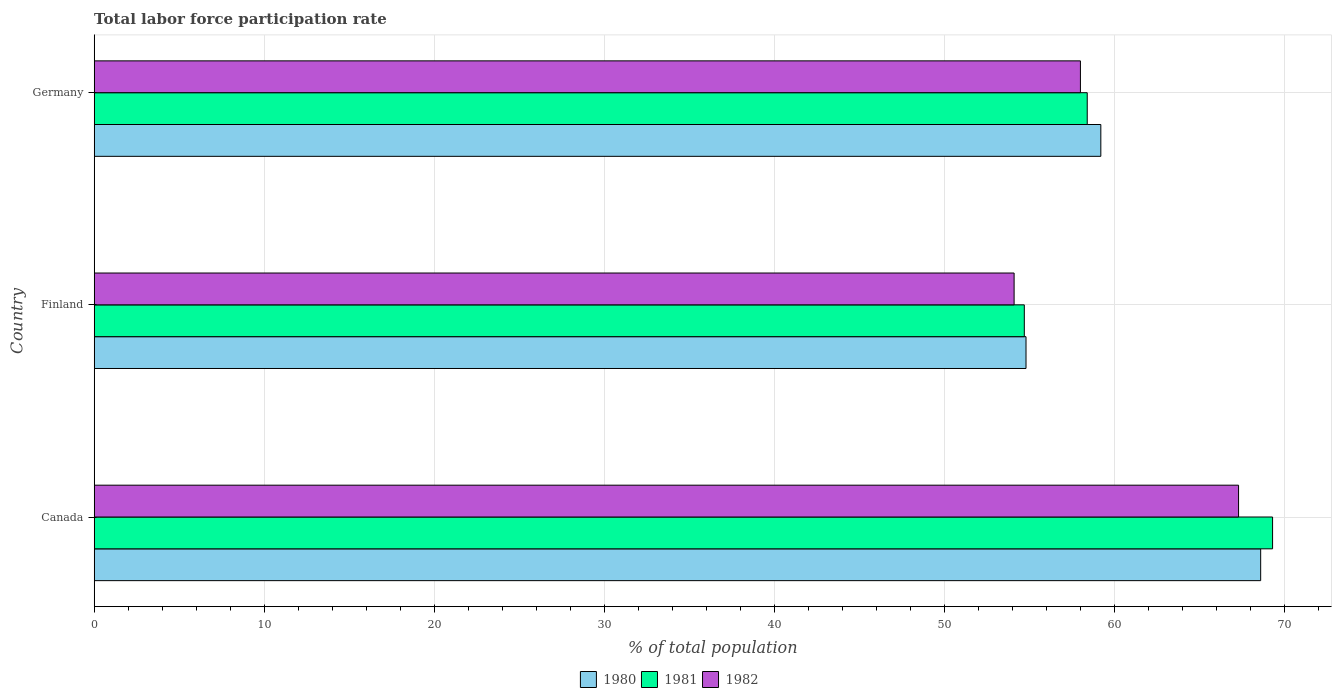How many different coloured bars are there?
Your answer should be compact. 3. How many groups of bars are there?
Make the answer very short. 3. Are the number of bars per tick equal to the number of legend labels?
Offer a terse response. Yes. Are the number of bars on each tick of the Y-axis equal?
Your answer should be compact. Yes. How many bars are there on the 1st tick from the bottom?
Your response must be concise. 3. What is the label of the 1st group of bars from the top?
Your response must be concise. Germany. In how many cases, is the number of bars for a given country not equal to the number of legend labels?
Provide a short and direct response. 0. What is the total labor force participation rate in 1981 in Germany?
Your answer should be compact. 58.4. Across all countries, what is the maximum total labor force participation rate in 1982?
Keep it short and to the point. 67.3. Across all countries, what is the minimum total labor force participation rate in 1982?
Make the answer very short. 54.1. What is the total total labor force participation rate in 1982 in the graph?
Your response must be concise. 179.4. What is the difference between the total labor force participation rate in 1981 in Canada and that in Germany?
Provide a short and direct response. 10.9. What is the difference between the total labor force participation rate in 1982 in Germany and the total labor force participation rate in 1980 in Finland?
Offer a very short reply. 3.2. What is the average total labor force participation rate in 1980 per country?
Provide a succinct answer. 60.87. What is the difference between the total labor force participation rate in 1981 and total labor force participation rate in 1982 in Germany?
Give a very brief answer. 0.4. In how many countries, is the total labor force participation rate in 1980 greater than 58 %?
Keep it short and to the point. 2. What is the ratio of the total labor force participation rate in 1981 in Canada to that in Germany?
Ensure brevity in your answer.  1.19. Is the difference between the total labor force participation rate in 1981 in Canada and Finland greater than the difference between the total labor force participation rate in 1982 in Canada and Finland?
Your answer should be very brief. Yes. What is the difference between the highest and the second highest total labor force participation rate in 1982?
Make the answer very short. 9.3. What is the difference between the highest and the lowest total labor force participation rate in 1980?
Keep it short and to the point. 13.8. What does the 3rd bar from the top in Finland represents?
Your answer should be very brief. 1980. Is it the case that in every country, the sum of the total labor force participation rate in 1982 and total labor force participation rate in 1980 is greater than the total labor force participation rate in 1981?
Make the answer very short. Yes. How many bars are there?
Your response must be concise. 9. How many countries are there in the graph?
Keep it short and to the point. 3. Does the graph contain any zero values?
Offer a very short reply. No. How many legend labels are there?
Give a very brief answer. 3. What is the title of the graph?
Your answer should be very brief. Total labor force participation rate. What is the label or title of the X-axis?
Your answer should be very brief. % of total population. What is the % of total population in 1980 in Canada?
Your answer should be compact. 68.6. What is the % of total population in 1981 in Canada?
Ensure brevity in your answer.  69.3. What is the % of total population of 1982 in Canada?
Your answer should be compact. 67.3. What is the % of total population in 1980 in Finland?
Offer a very short reply. 54.8. What is the % of total population of 1981 in Finland?
Keep it short and to the point. 54.7. What is the % of total population of 1982 in Finland?
Keep it short and to the point. 54.1. What is the % of total population in 1980 in Germany?
Your response must be concise. 59.2. What is the % of total population in 1981 in Germany?
Ensure brevity in your answer.  58.4. Across all countries, what is the maximum % of total population of 1980?
Give a very brief answer. 68.6. Across all countries, what is the maximum % of total population of 1981?
Ensure brevity in your answer.  69.3. Across all countries, what is the maximum % of total population in 1982?
Offer a very short reply. 67.3. Across all countries, what is the minimum % of total population in 1980?
Offer a very short reply. 54.8. Across all countries, what is the minimum % of total population in 1981?
Offer a very short reply. 54.7. Across all countries, what is the minimum % of total population of 1982?
Give a very brief answer. 54.1. What is the total % of total population of 1980 in the graph?
Provide a succinct answer. 182.6. What is the total % of total population of 1981 in the graph?
Give a very brief answer. 182.4. What is the total % of total population of 1982 in the graph?
Provide a short and direct response. 179.4. What is the difference between the % of total population in 1982 in Canada and that in Finland?
Your answer should be compact. 13.2. What is the difference between the % of total population in 1980 in Canada and that in Germany?
Keep it short and to the point. 9.4. What is the difference between the % of total population in 1982 in Canada and that in Germany?
Your answer should be compact. 9.3. What is the difference between the % of total population in 1982 in Finland and that in Germany?
Offer a terse response. -3.9. What is the difference between the % of total population of 1981 in Canada and the % of total population of 1982 in Germany?
Your response must be concise. 11.3. What is the difference between the % of total population in 1980 in Finland and the % of total population in 1982 in Germany?
Ensure brevity in your answer.  -3.2. What is the difference between the % of total population of 1981 in Finland and the % of total population of 1982 in Germany?
Your answer should be very brief. -3.3. What is the average % of total population of 1980 per country?
Offer a terse response. 60.87. What is the average % of total population in 1981 per country?
Your answer should be very brief. 60.8. What is the average % of total population of 1982 per country?
Offer a very short reply. 59.8. What is the difference between the % of total population of 1980 and % of total population of 1981 in Canada?
Provide a short and direct response. -0.7. What is the difference between the % of total population in 1981 and % of total population in 1982 in Canada?
Offer a terse response. 2. What is the difference between the % of total population in 1980 and % of total population in 1981 in Finland?
Offer a very short reply. 0.1. What is the ratio of the % of total population in 1980 in Canada to that in Finland?
Provide a succinct answer. 1.25. What is the ratio of the % of total population of 1981 in Canada to that in Finland?
Your answer should be compact. 1.27. What is the ratio of the % of total population in 1982 in Canada to that in Finland?
Your answer should be compact. 1.24. What is the ratio of the % of total population in 1980 in Canada to that in Germany?
Your response must be concise. 1.16. What is the ratio of the % of total population of 1981 in Canada to that in Germany?
Offer a very short reply. 1.19. What is the ratio of the % of total population of 1982 in Canada to that in Germany?
Ensure brevity in your answer.  1.16. What is the ratio of the % of total population in 1980 in Finland to that in Germany?
Offer a very short reply. 0.93. What is the ratio of the % of total population of 1981 in Finland to that in Germany?
Keep it short and to the point. 0.94. What is the ratio of the % of total population of 1982 in Finland to that in Germany?
Make the answer very short. 0.93. What is the difference between the highest and the second highest % of total population of 1980?
Your response must be concise. 9.4. 